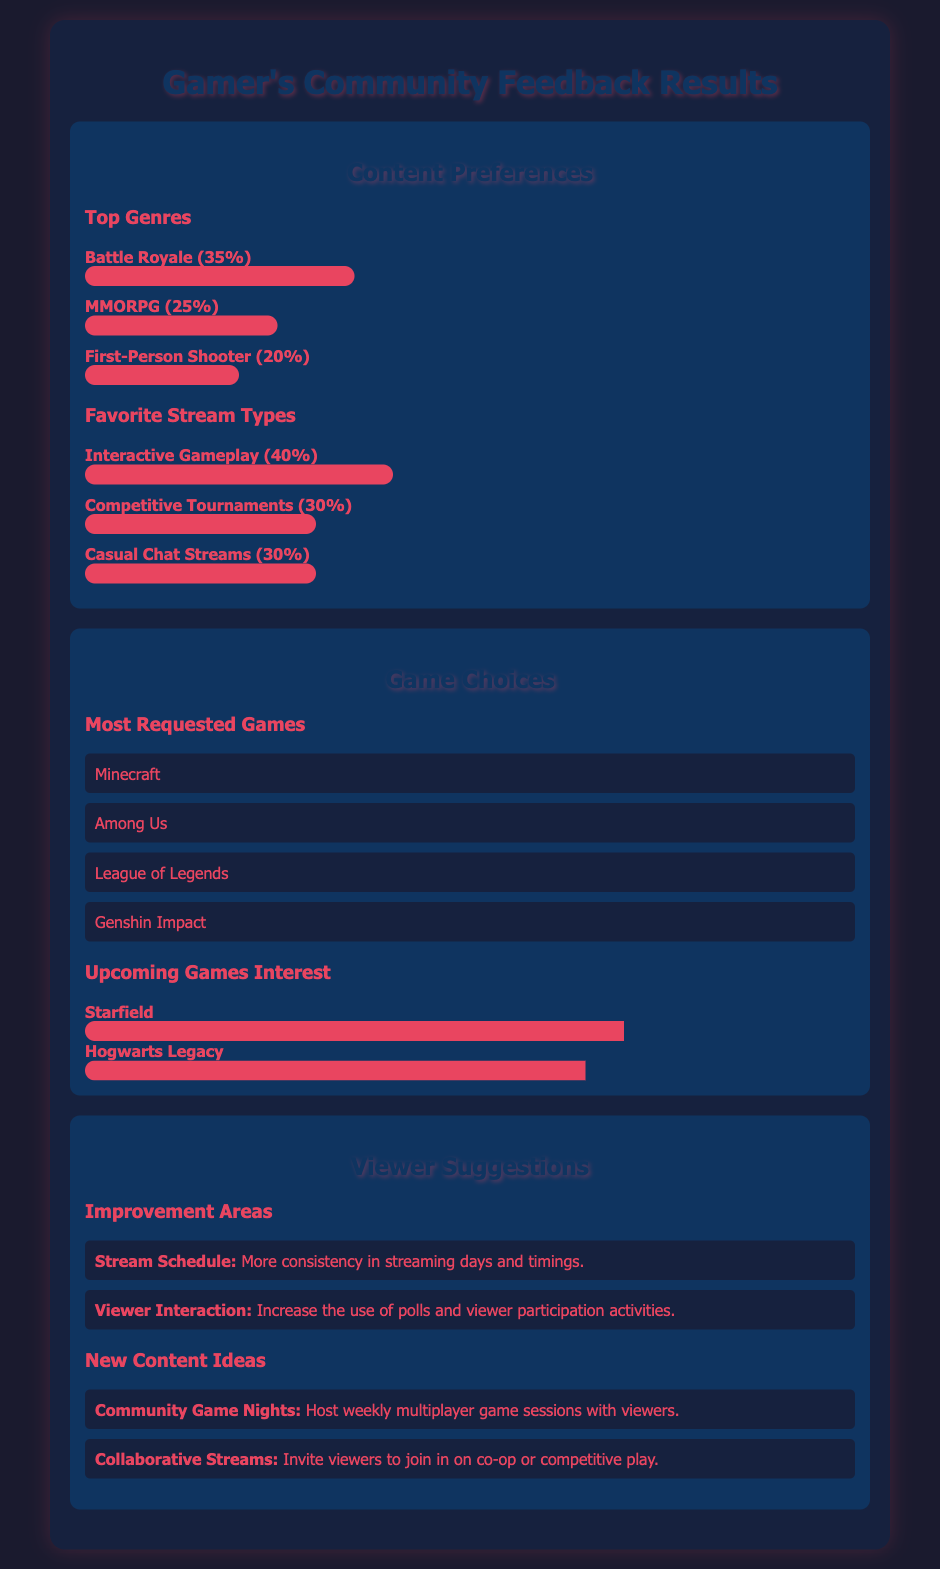What is the most popular genre according to the survey? The survey results indicate that the most popular genre is Battle Royale, which received 35% of responses.
Answer: Battle Royale What percentage of viewers prefer Interactive Gameplay streams? According to the feedback, 40% of viewers prefer Interactive Gameplay streams as their favorite stream type.
Answer: 40% Which game received the highest interest for upcoming games? The game with the highest interest among upcoming titles is Starfield, indicated by a 70% interest level.
Answer: Starfield What are the top two requested games? The most requested games based on viewer responses are Minecraft and Among Us.
Answer: Minecraft, Among Us What suggestion was made regarding viewer interaction? One of the suggestions for improvement was to increase the use of polls and viewer participation activities.
Answer: Increase polls How much interest is there in Hogwarts Legacy? The interest level for Hogwarts Legacy is represented by a 65% interest meter.
Answer: 65% What type of content did viewers suggest for future streams? Viewers suggested hosting Community Game Nights as a new content idea for future streams.
Answer: Community Game Nights What is the percentage of viewers that prefer Competitive Tournaments? The survey indicates that 30% of viewers prefer Competitive Tournaments as a type of stream.
Answer: 30% How many viewers suggested improvement in stream schedule? Two main suggestions were noted including more consistency in streaming days and timings.
Answer: Two 